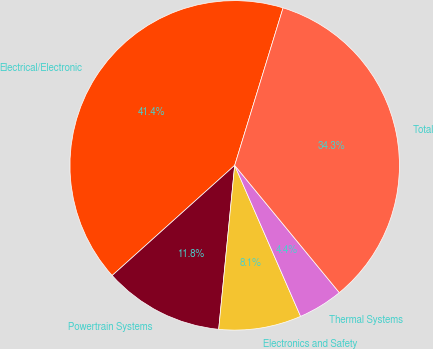Convert chart to OTSL. <chart><loc_0><loc_0><loc_500><loc_500><pie_chart><fcel>Electrical/Electronic<fcel>Powertrain Systems<fcel>Electronics and Safety<fcel>Thermal Systems<fcel>Total<nl><fcel>41.4%<fcel>11.8%<fcel>8.1%<fcel>4.4%<fcel>34.31%<nl></chart> 